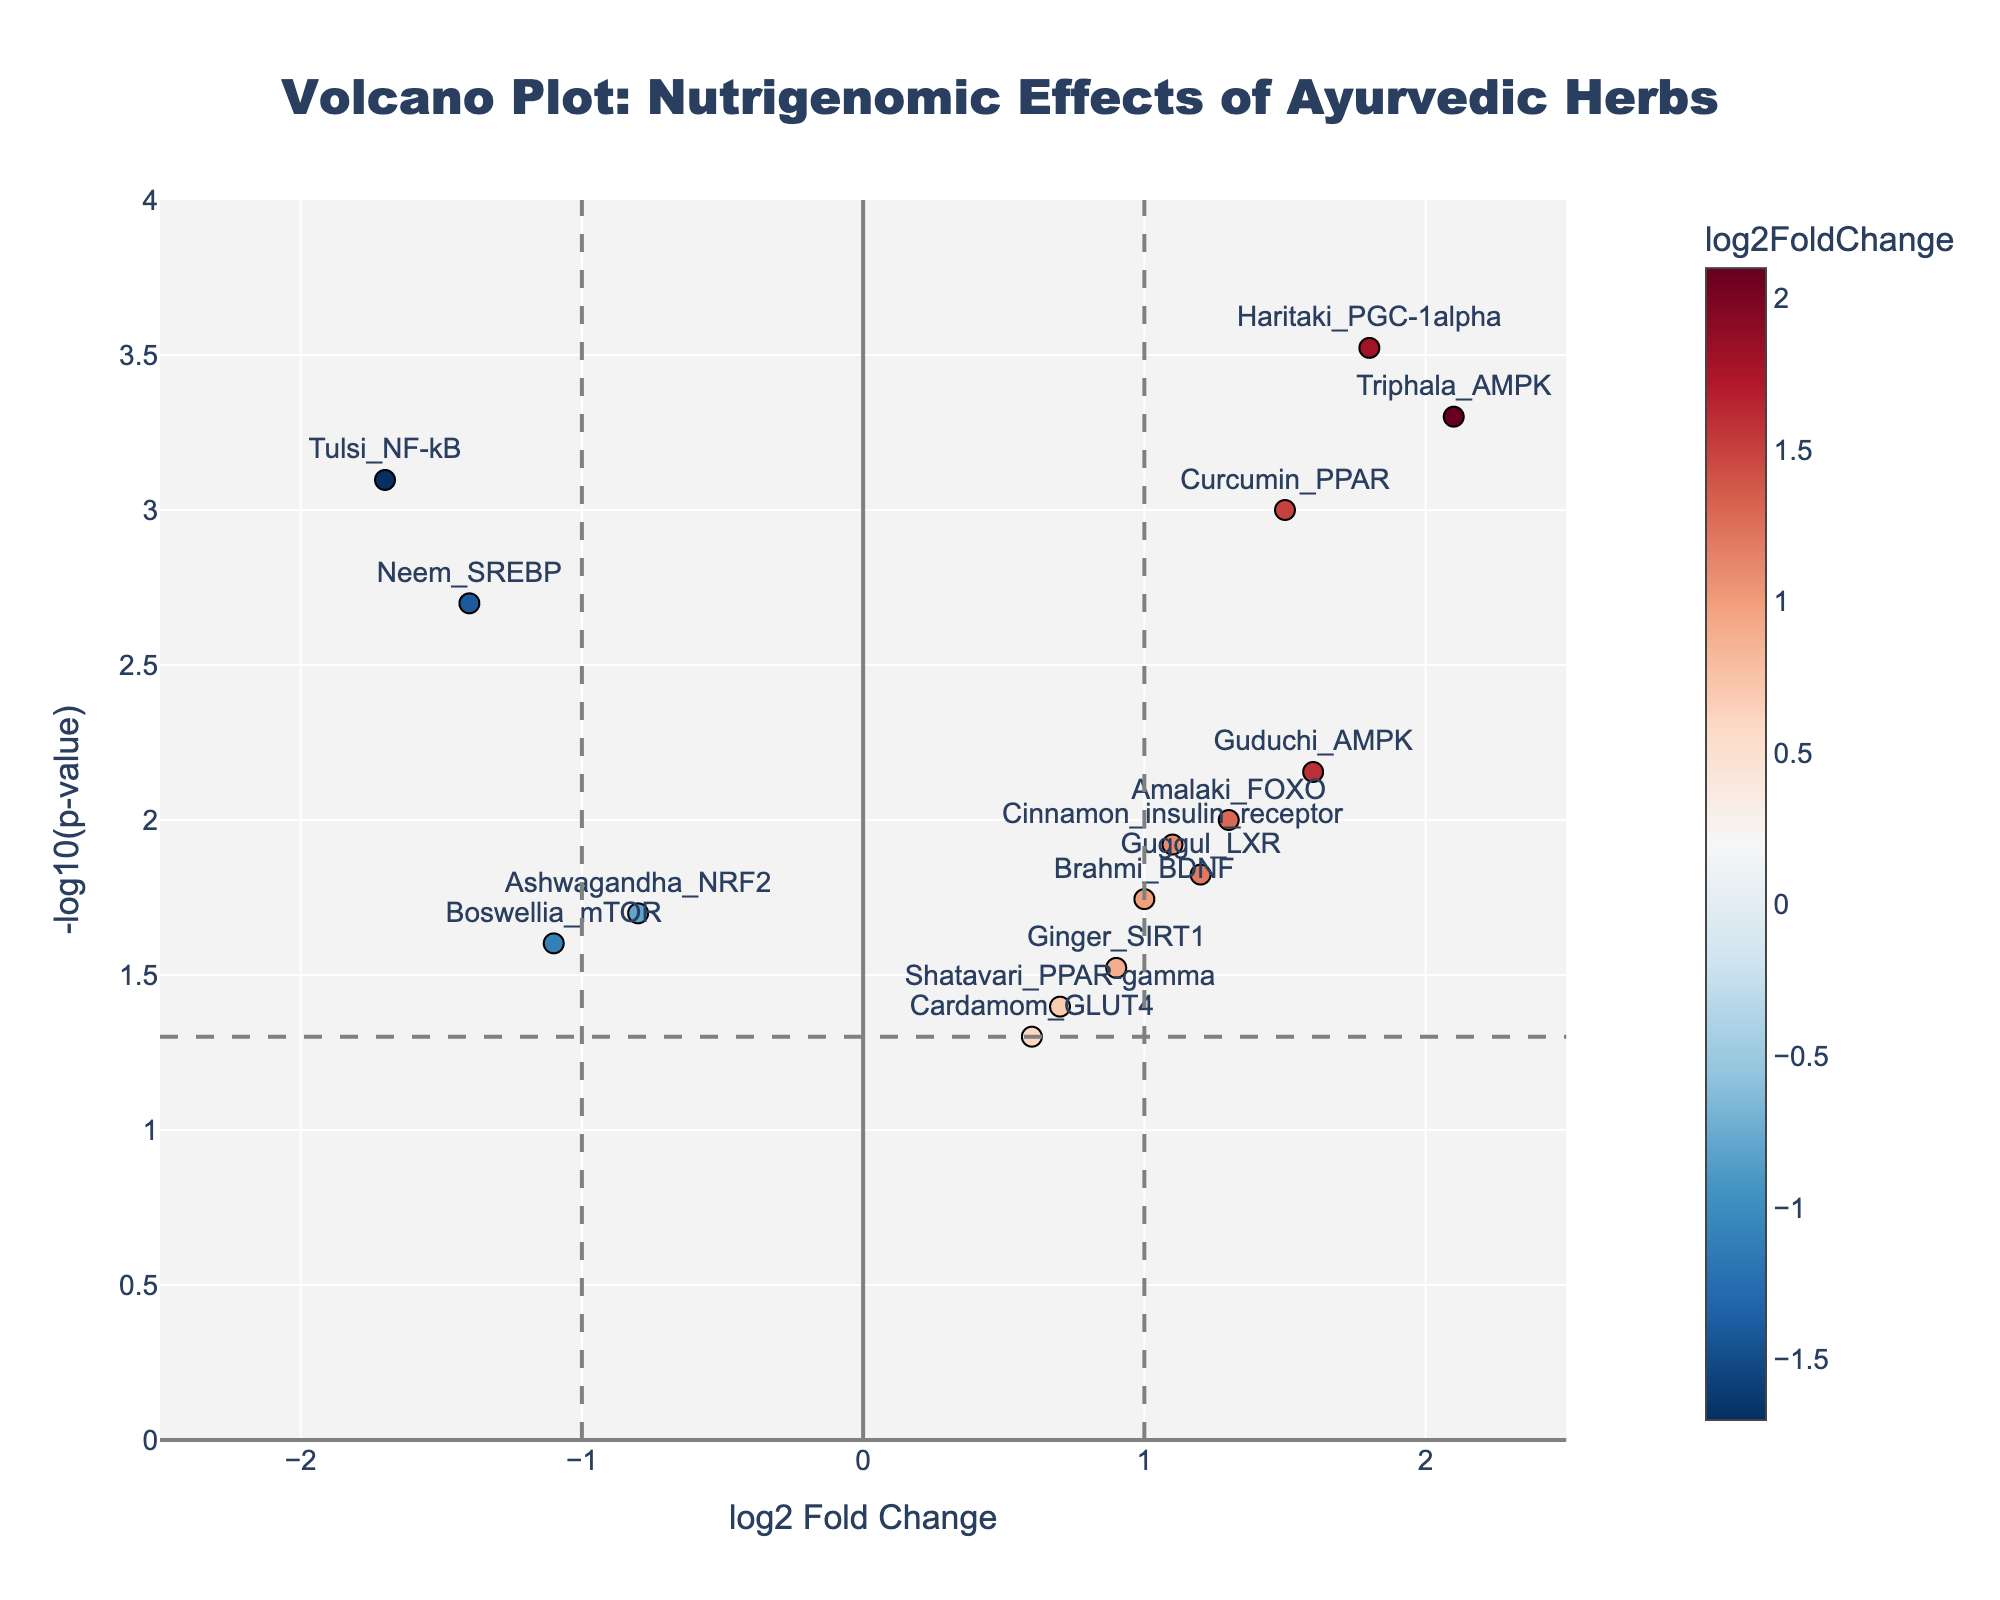what's the title of the figure? The title is prominently displayed at the top of the figure.
Answer: "Volcano Plot: Nutrigenomic Effects of Ayurvedic Herbs" how many data points are in the plot? Count the number of markers representing data points in the plot.
Answer: 15 Which Ayurvedic herb has the highest log2FoldChange? Look for the data point with the highest value on the x-axis.
Answer: Triphala What's the range of p-values shown in the plot? Determine the range by looking at the values on the y-axis in the plot, which represent -log10(p-value) and can be converted back to p-values.
Answer: Between 0.0003 and 0.05 how many data points have a p-value less than 0.01? Count the number of data points above the horizontal threshold line for -log10(p-value) at approximately 2.
Answer: 8 Which gene is associated with the highest -log10(p-value)? Identify the data point with the highest value on the y-axis.
Answer: Triphala_AMPK What are the log2 fold changes for genes with p-values less than 0.01? Identify the data points above the horizontal threshold line and read their x-axis values.
Answer: 1.5 (Curcumin_PPAR), 2.1 (Triphala_AMPK), 1.8 (Haritaki_PGC-1alpha), 1.6 (Guduchi_AMPK), -1.7 (Tulsi_NF-kB), -1.4 (Neem_SREBP) Which herb affects AMPK the most? Look for the data points labeled with AMPK and compare their -log10(p-value) and log2FoldChange values.
Answer: Triphala What is the log2FoldChange and p-value of Curcumin_PPAR? Refer to the hover text or the placements on the axes.
Answer: log2FoldChange: 1.5, p-value: 0.001 how many genes show both significant fold change (greater than 1 or less than -1) and significant p-value (less than 0.05)? Count the data points that lie beyond the vertical lines (for fold change) and above the horizontal line (for p-value).
Answer: 5 